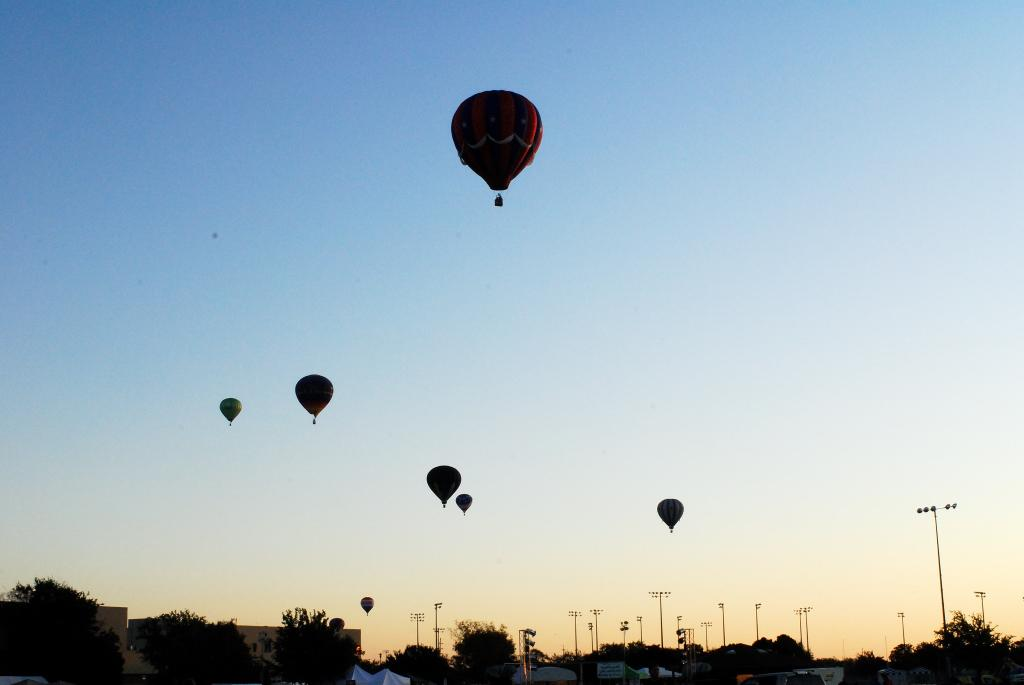What is flying in the air in the image? There are gas balloons flying flying in the air in the image. What can be seen at the bottom of the image? There are trees and poles at the bottom of the image. What is visible at the top of the image? The sky is visible at the top of the image. What type of vegetable is growing on the gas balloons in the image? There are no vegetables present on the gas balloons in the image. Can you tell me how many fire hydrants are visible in the image? There are no fire hydrants present in the image. 